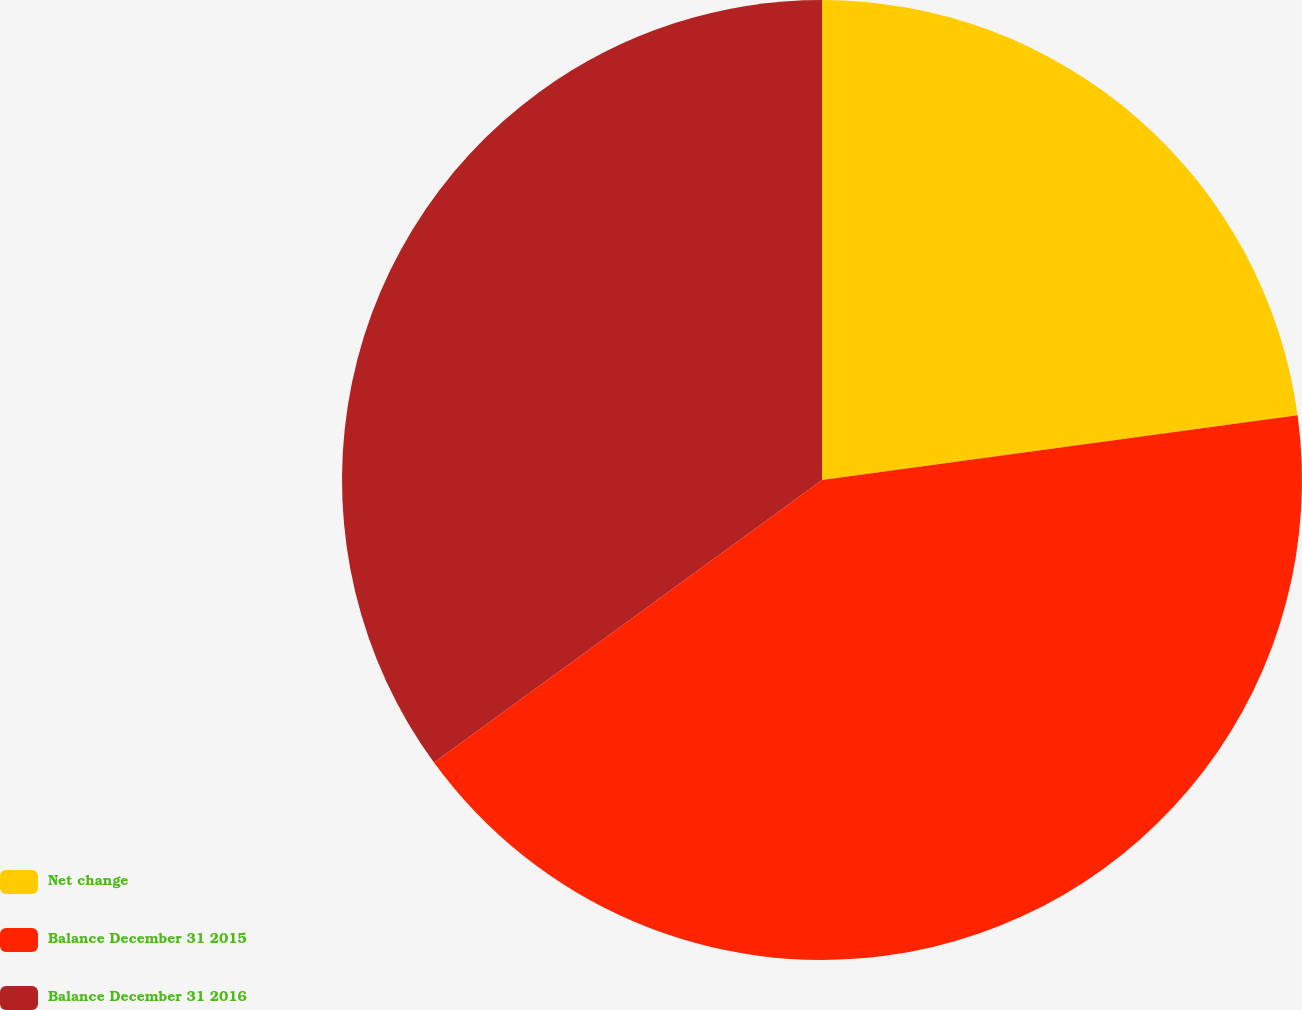Convert chart to OTSL. <chart><loc_0><loc_0><loc_500><loc_500><pie_chart><fcel>Net change<fcel>Balance December 31 2015<fcel>Balance December 31 2016<nl><fcel>22.85%<fcel>42.14%<fcel>35.02%<nl></chart> 